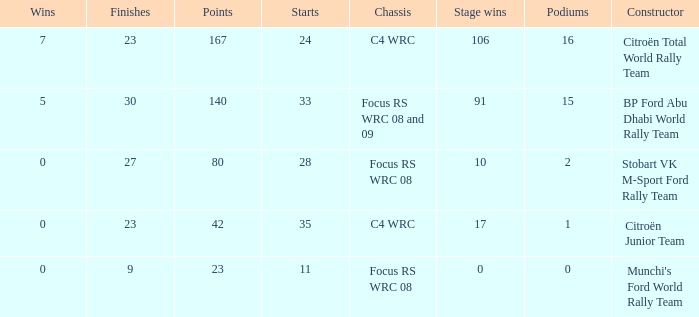What is the average wins when the podiums is more than 1, points is 80 and starts is less than 28? None. Could you parse the entire table? {'header': ['Wins', 'Finishes', 'Points', 'Starts', 'Chassis', 'Stage wins', 'Podiums', 'Constructor'], 'rows': [['7', '23', '167', '24', 'C4 WRC', '106', '16', 'Citroën Total World Rally Team'], ['5', '30', '140', '33', 'Focus RS WRC 08 and 09', '91', '15', 'BP Ford Abu Dhabi World Rally Team'], ['0', '27', '80', '28', 'Focus RS WRC 08', '10', '2', 'Stobart VK M-Sport Ford Rally Team'], ['0', '23', '42', '35', 'C4 WRC', '17', '1', 'Citroën Junior Team'], ['0', '9', '23', '11', 'Focus RS WRC 08', '0', '0', "Munchi's Ford World Rally Team"]]} 